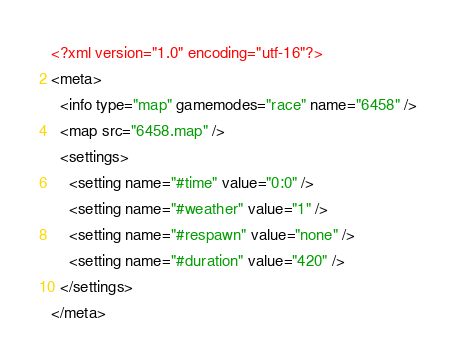Convert code to text. <code><loc_0><loc_0><loc_500><loc_500><_XML_><?xml version="1.0" encoding="utf-16"?>
<meta>
  <info type="map" gamemodes="race" name="6458" />
  <map src="6458.map" />
  <settings>
    <setting name="#time" value="0:0" />
    <setting name="#weather" value="1" />
    <setting name="#respawn" value="none" />
    <setting name="#duration" value="420" />
  </settings>
</meta></code> 